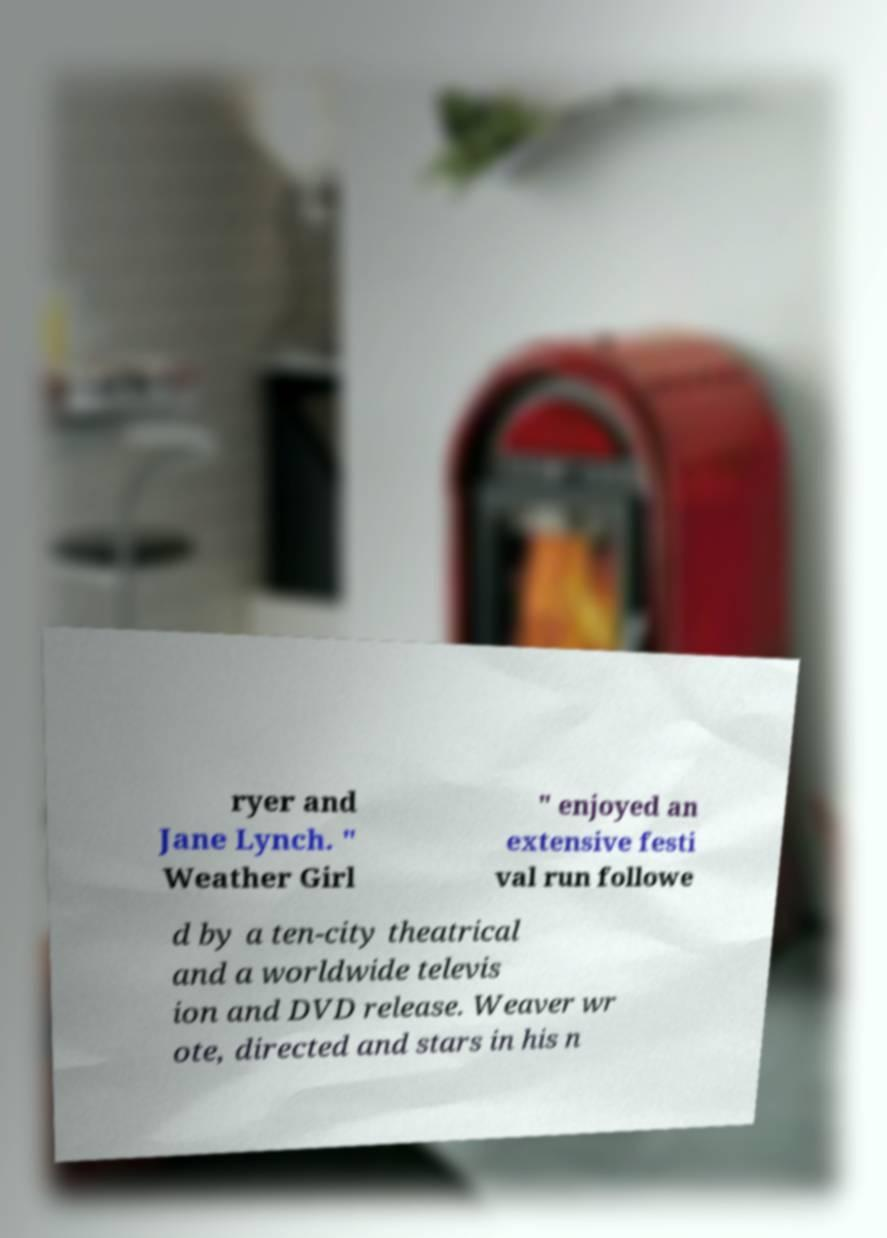Please read and relay the text visible in this image. What does it say? ryer and Jane Lynch. " Weather Girl " enjoyed an extensive festi val run followe d by a ten-city theatrical and a worldwide televis ion and DVD release. Weaver wr ote, directed and stars in his n 